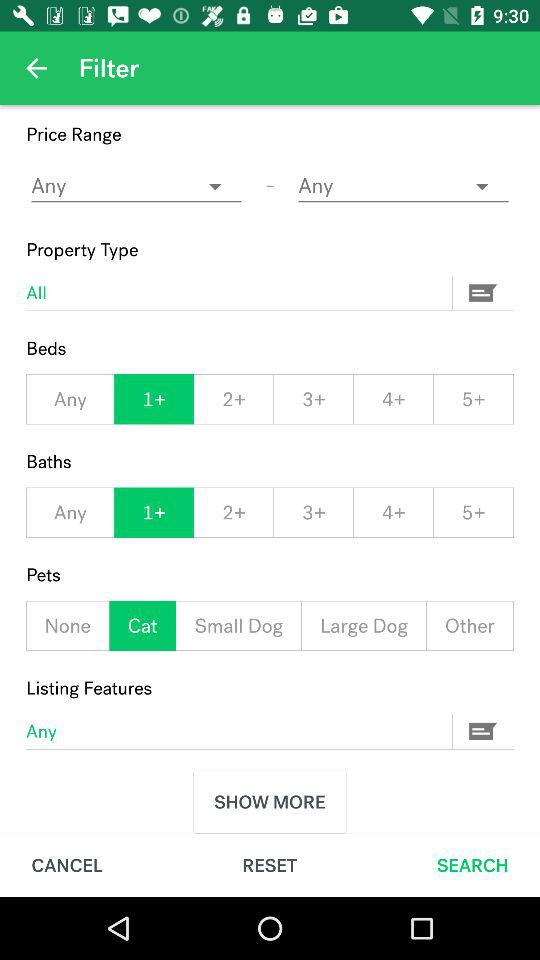Which option is selected in "Pets"? The selected option in "Pets" is "Cat". 